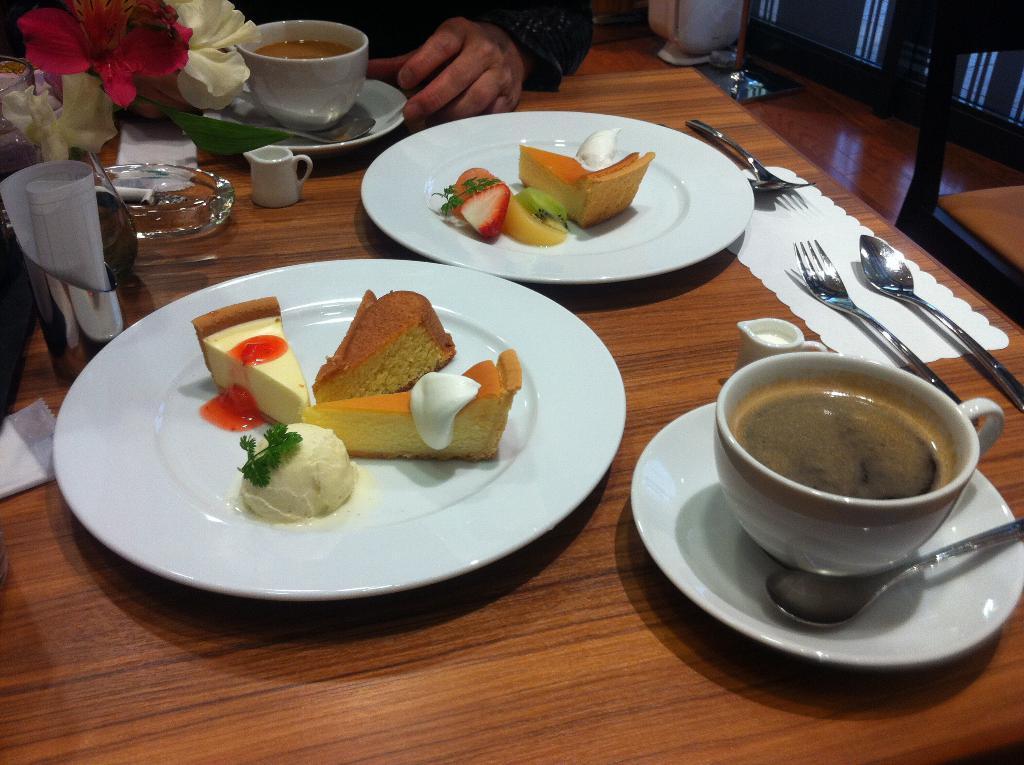Describe this image in one or two sentences. At the bottom of the image there is table. On the table there are plates with food items, cup with saucer and a spoon. And also there are forks, spoons, bowls, flowers and some other things. At the top of the image there is a hand of a person on the table. On the right side of the image there is a chair. 